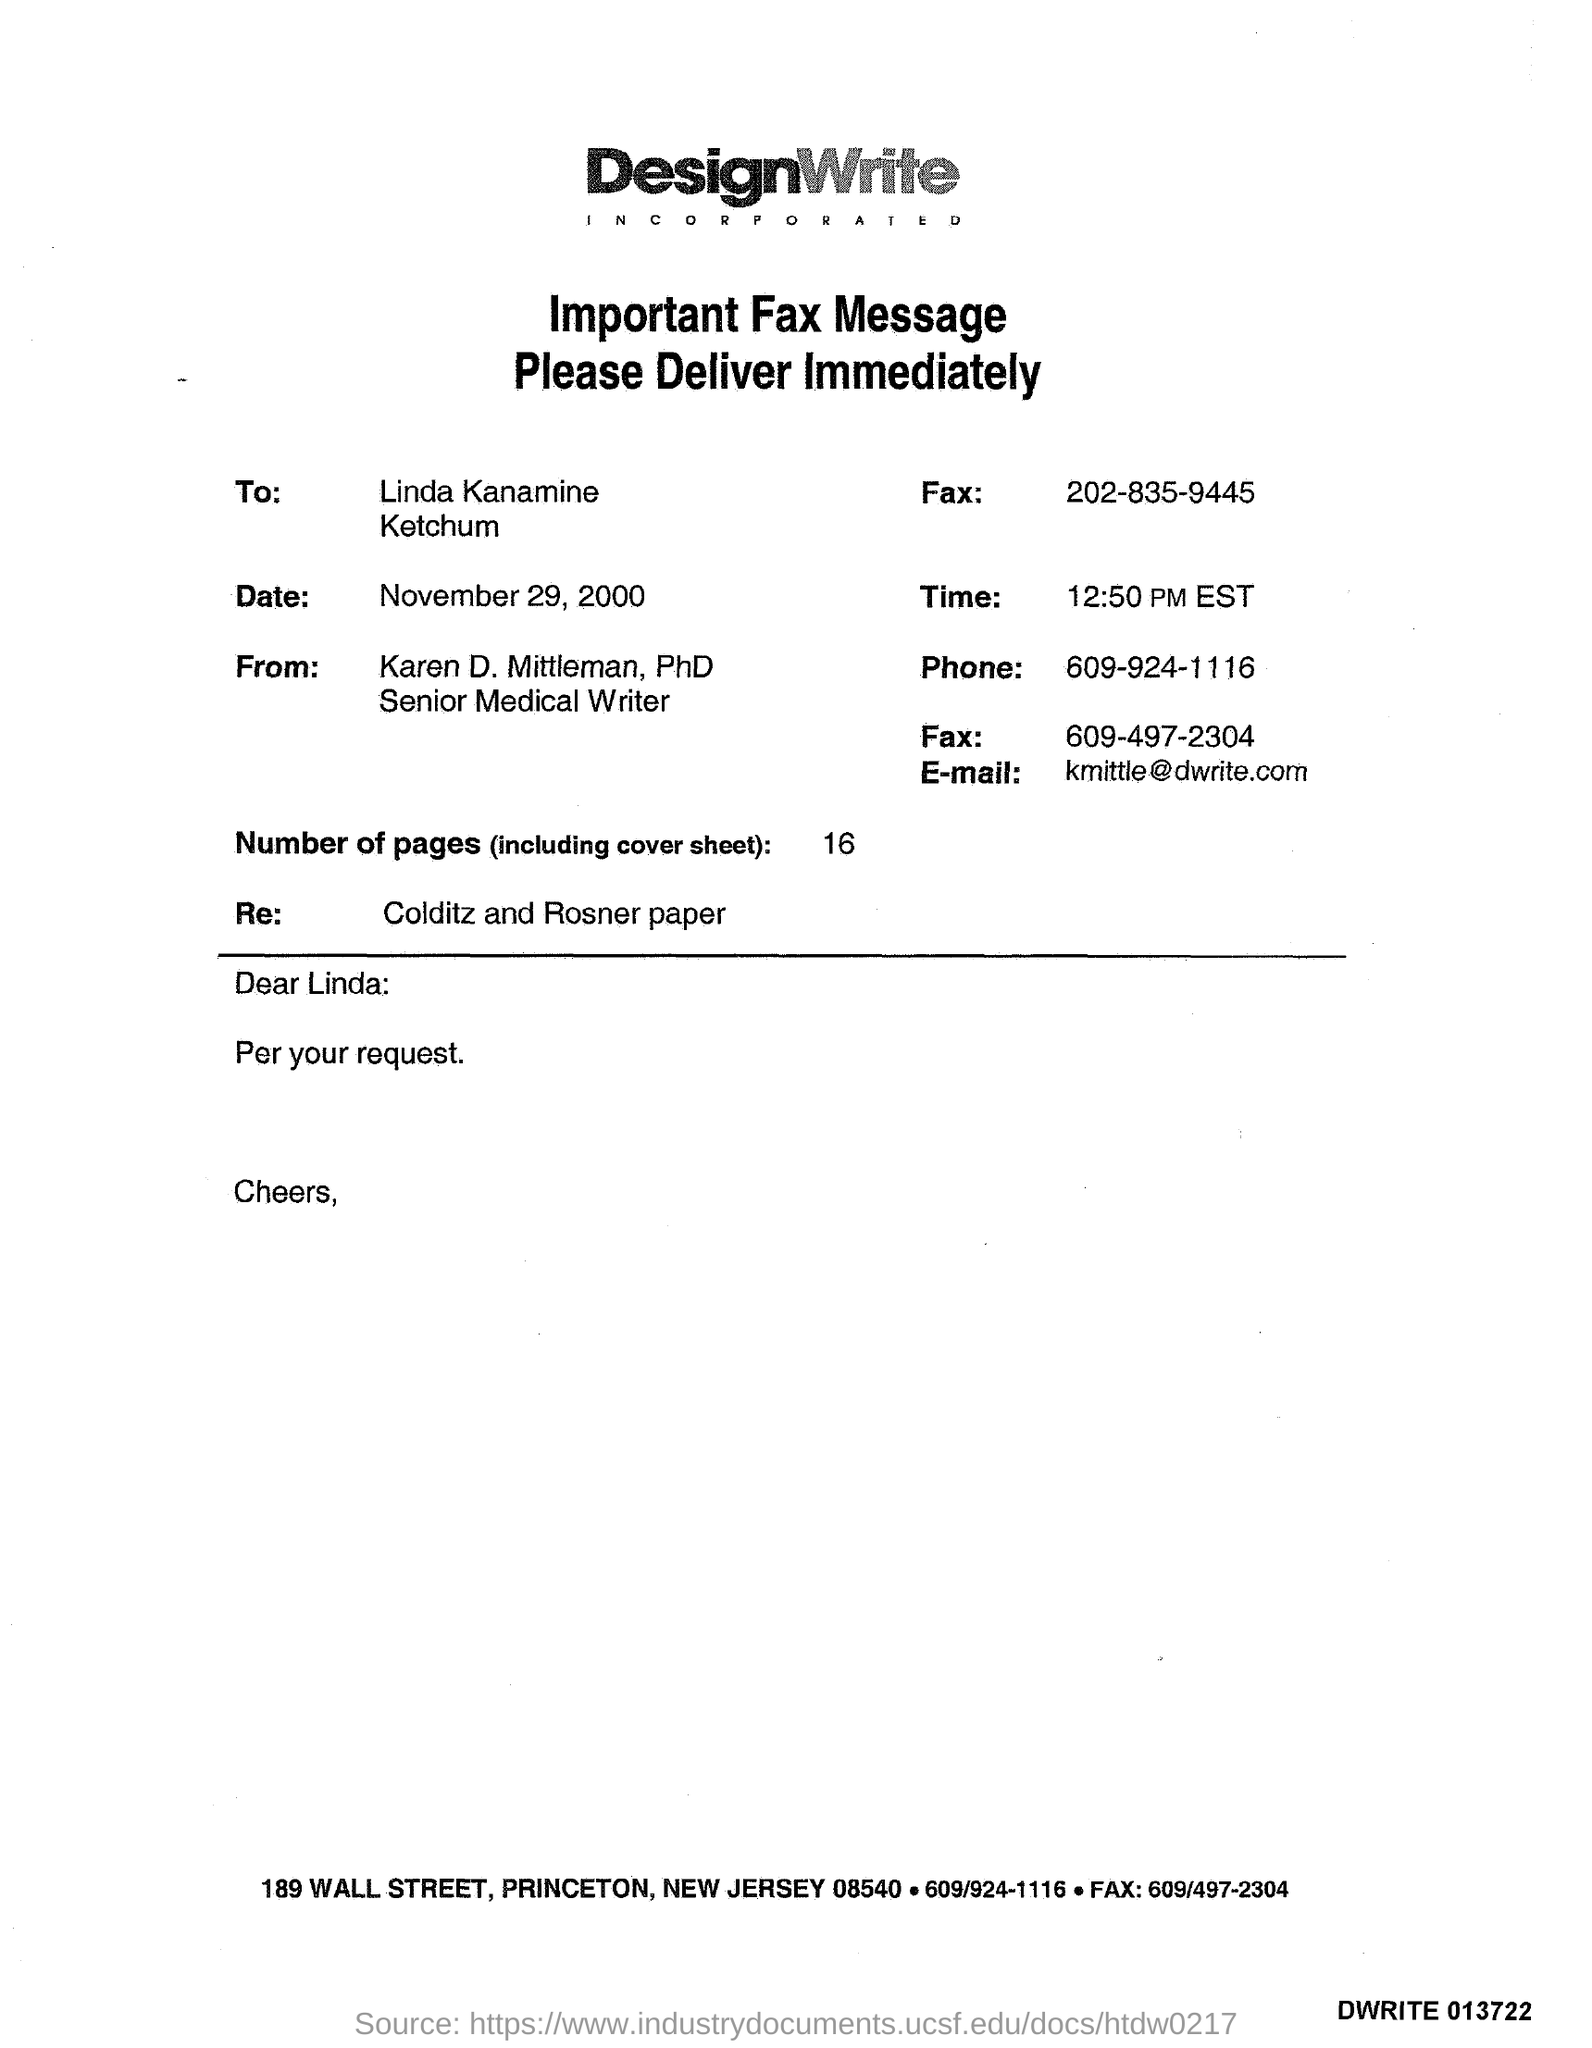What is the date?
Your response must be concise. November 29, 2000. What is the salutation of this letter?
Provide a short and direct response. Dear Linda:. What is the E- mail address?
Your answer should be very brief. Kmittle@dwrite.com. What is the time?
Your answer should be very brief. 12:50 PM EST. What is the phone number?
Keep it short and to the point. 609-924-1116. 